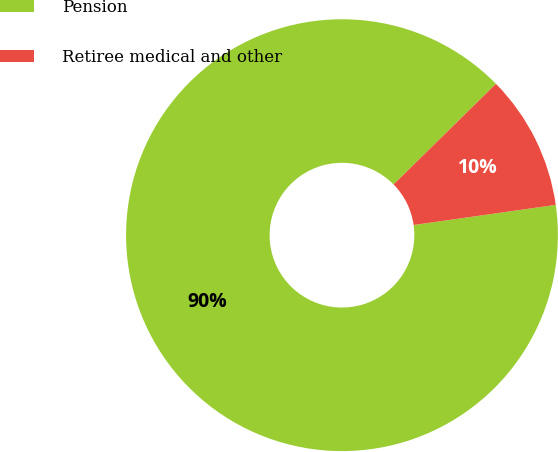Convert chart. <chart><loc_0><loc_0><loc_500><loc_500><pie_chart><fcel>Pension<fcel>Retiree medical and other<nl><fcel>89.88%<fcel>10.12%<nl></chart> 